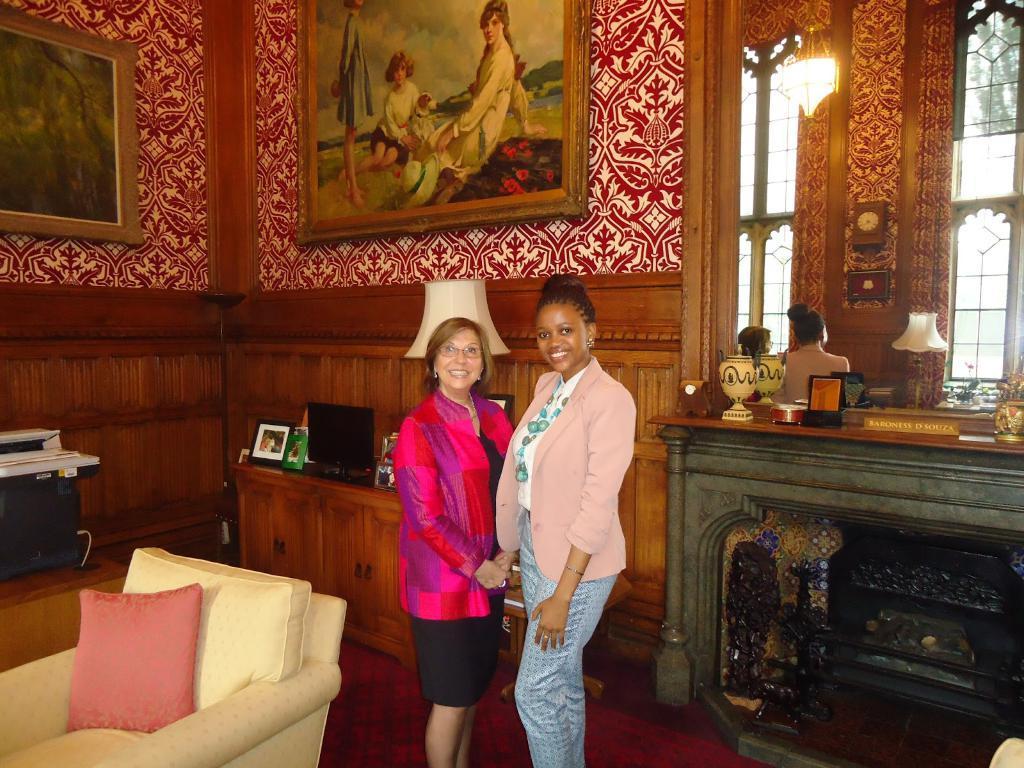Could you give a brief overview of what you see in this image? In the image we can see there are women standing, there is a chair and pink colour cushion kept on the chair. There are photo frames kept on the wall and there is a monitor and table lamp kept on the table. There is mirror on the wall. 